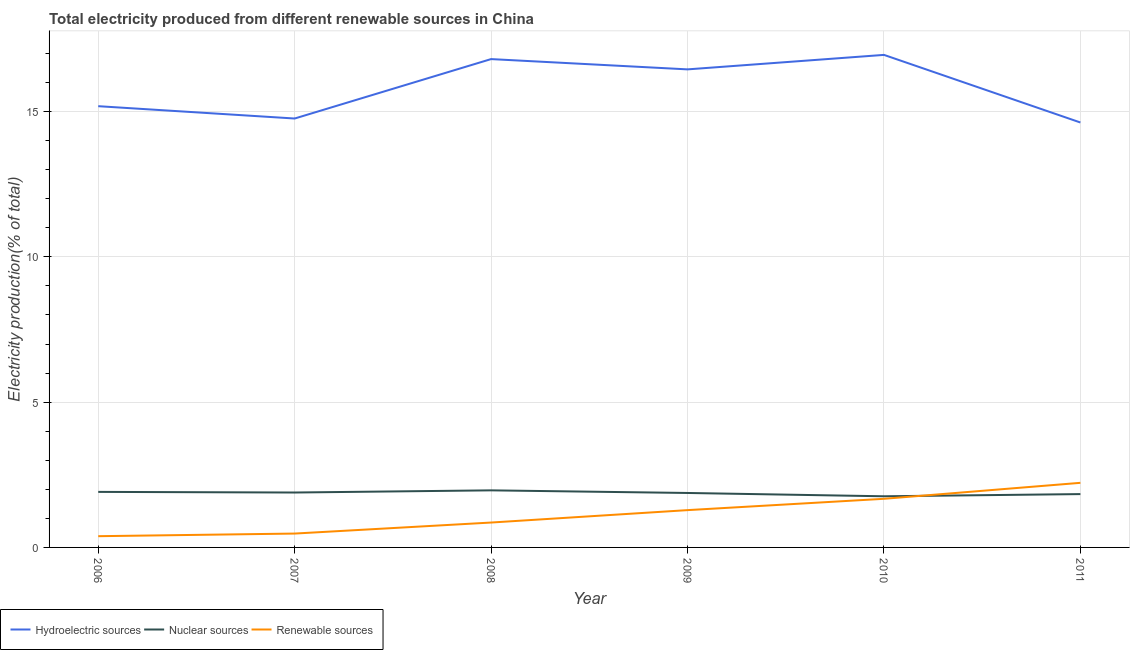Does the line corresponding to percentage of electricity produced by hydroelectric sources intersect with the line corresponding to percentage of electricity produced by renewable sources?
Give a very brief answer. No. Is the number of lines equal to the number of legend labels?
Provide a short and direct response. Yes. What is the percentage of electricity produced by nuclear sources in 2011?
Offer a terse response. 1.84. Across all years, what is the maximum percentage of electricity produced by renewable sources?
Keep it short and to the point. 2.22. Across all years, what is the minimum percentage of electricity produced by nuclear sources?
Your answer should be compact. 1.76. In which year was the percentage of electricity produced by hydroelectric sources maximum?
Keep it short and to the point. 2010. What is the total percentage of electricity produced by renewable sources in the graph?
Make the answer very short. 6.9. What is the difference between the percentage of electricity produced by hydroelectric sources in 2006 and that in 2007?
Provide a short and direct response. 0.42. What is the difference between the percentage of electricity produced by hydroelectric sources in 2006 and the percentage of electricity produced by renewable sources in 2011?
Provide a succinct answer. 12.96. What is the average percentage of electricity produced by renewable sources per year?
Ensure brevity in your answer.  1.15. In the year 2006, what is the difference between the percentage of electricity produced by hydroelectric sources and percentage of electricity produced by renewable sources?
Keep it short and to the point. 14.8. In how many years, is the percentage of electricity produced by nuclear sources greater than 1 %?
Offer a terse response. 6. What is the ratio of the percentage of electricity produced by nuclear sources in 2009 to that in 2010?
Make the answer very short. 1.06. Is the percentage of electricity produced by nuclear sources in 2009 less than that in 2011?
Your answer should be very brief. No. What is the difference between the highest and the second highest percentage of electricity produced by nuclear sources?
Provide a short and direct response. 0.05. What is the difference between the highest and the lowest percentage of electricity produced by hydroelectric sources?
Your answer should be compact. 2.33. Is the sum of the percentage of electricity produced by hydroelectric sources in 2007 and 2009 greater than the maximum percentage of electricity produced by nuclear sources across all years?
Give a very brief answer. Yes. Is the percentage of electricity produced by nuclear sources strictly greater than the percentage of electricity produced by renewable sources over the years?
Ensure brevity in your answer.  No. Is the percentage of electricity produced by renewable sources strictly less than the percentage of electricity produced by hydroelectric sources over the years?
Your answer should be very brief. Yes. What is the difference between two consecutive major ticks on the Y-axis?
Offer a very short reply. 5. Are the values on the major ticks of Y-axis written in scientific E-notation?
Your answer should be compact. No. Where does the legend appear in the graph?
Ensure brevity in your answer.  Bottom left. How are the legend labels stacked?
Your answer should be compact. Horizontal. What is the title of the graph?
Offer a very short reply. Total electricity produced from different renewable sources in China. Does "Ages 20-50" appear as one of the legend labels in the graph?
Your response must be concise. No. What is the label or title of the X-axis?
Make the answer very short. Year. What is the label or title of the Y-axis?
Offer a very short reply. Electricity production(% of total). What is the Electricity production(% of total) in Hydroelectric sources in 2006?
Provide a short and direct response. 15.19. What is the Electricity production(% of total) of Nuclear sources in 2006?
Offer a terse response. 1.91. What is the Electricity production(% of total) of Renewable sources in 2006?
Your answer should be compact. 0.39. What is the Electricity production(% of total) of Hydroelectric sources in 2007?
Make the answer very short. 14.76. What is the Electricity production(% of total) in Nuclear sources in 2007?
Keep it short and to the point. 1.89. What is the Electricity production(% of total) in Renewable sources in 2007?
Your answer should be very brief. 0.48. What is the Electricity production(% of total) of Hydroelectric sources in 2008?
Provide a short and direct response. 16.81. What is the Electricity production(% of total) in Nuclear sources in 2008?
Give a very brief answer. 1.96. What is the Electricity production(% of total) in Renewable sources in 2008?
Give a very brief answer. 0.86. What is the Electricity production(% of total) in Hydroelectric sources in 2009?
Make the answer very short. 16.45. What is the Electricity production(% of total) of Nuclear sources in 2009?
Offer a very short reply. 1.87. What is the Electricity production(% of total) in Renewable sources in 2009?
Make the answer very short. 1.28. What is the Electricity production(% of total) of Hydroelectric sources in 2010?
Offer a terse response. 16.95. What is the Electricity production(% of total) in Nuclear sources in 2010?
Ensure brevity in your answer.  1.76. What is the Electricity production(% of total) in Renewable sources in 2010?
Your response must be concise. 1.67. What is the Electricity production(% of total) of Hydroelectric sources in 2011?
Offer a terse response. 14.62. What is the Electricity production(% of total) of Nuclear sources in 2011?
Give a very brief answer. 1.84. What is the Electricity production(% of total) in Renewable sources in 2011?
Provide a short and direct response. 2.22. Across all years, what is the maximum Electricity production(% of total) in Hydroelectric sources?
Ensure brevity in your answer.  16.95. Across all years, what is the maximum Electricity production(% of total) of Nuclear sources?
Give a very brief answer. 1.96. Across all years, what is the maximum Electricity production(% of total) in Renewable sources?
Make the answer very short. 2.22. Across all years, what is the minimum Electricity production(% of total) of Hydroelectric sources?
Your answer should be very brief. 14.62. Across all years, what is the minimum Electricity production(% of total) of Nuclear sources?
Give a very brief answer. 1.76. Across all years, what is the minimum Electricity production(% of total) in Renewable sources?
Make the answer very short. 0.39. What is the total Electricity production(% of total) in Hydroelectric sources in the graph?
Offer a very short reply. 94.78. What is the total Electricity production(% of total) in Nuclear sources in the graph?
Give a very brief answer. 11.23. What is the total Electricity production(% of total) of Renewable sources in the graph?
Offer a terse response. 6.9. What is the difference between the Electricity production(% of total) in Hydroelectric sources in 2006 and that in 2007?
Your answer should be compact. 0.42. What is the difference between the Electricity production(% of total) in Nuclear sources in 2006 and that in 2007?
Your response must be concise. 0.02. What is the difference between the Electricity production(% of total) of Renewable sources in 2006 and that in 2007?
Provide a succinct answer. -0.09. What is the difference between the Electricity production(% of total) in Hydroelectric sources in 2006 and that in 2008?
Provide a short and direct response. -1.62. What is the difference between the Electricity production(% of total) of Nuclear sources in 2006 and that in 2008?
Make the answer very short. -0.05. What is the difference between the Electricity production(% of total) of Renewable sources in 2006 and that in 2008?
Provide a succinct answer. -0.47. What is the difference between the Electricity production(% of total) in Hydroelectric sources in 2006 and that in 2009?
Provide a succinct answer. -1.27. What is the difference between the Electricity production(% of total) in Nuclear sources in 2006 and that in 2009?
Your answer should be compact. 0.04. What is the difference between the Electricity production(% of total) of Renewable sources in 2006 and that in 2009?
Offer a terse response. -0.9. What is the difference between the Electricity production(% of total) of Hydroelectric sources in 2006 and that in 2010?
Keep it short and to the point. -1.77. What is the difference between the Electricity production(% of total) in Nuclear sources in 2006 and that in 2010?
Ensure brevity in your answer.  0.15. What is the difference between the Electricity production(% of total) in Renewable sources in 2006 and that in 2010?
Provide a succinct answer. -1.29. What is the difference between the Electricity production(% of total) in Hydroelectric sources in 2006 and that in 2011?
Your answer should be very brief. 0.56. What is the difference between the Electricity production(% of total) of Nuclear sources in 2006 and that in 2011?
Provide a short and direct response. 0.08. What is the difference between the Electricity production(% of total) in Renewable sources in 2006 and that in 2011?
Your answer should be compact. -1.84. What is the difference between the Electricity production(% of total) in Hydroelectric sources in 2007 and that in 2008?
Your response must be concise. -2.05. What is the difference between the Electricity production(% of total) in Nuclear sources in 2007 and that in 2008?
Keep it short and to the point. -0.07. What is the difference between the Electricity production(% of total) of Renewable sources in 2007 and that in 2008?
Your answer should be very brief. -0.38. What is the difference between the Electricity production(% of total) of Hydroelectric sources in 2007 and that in 2009?
Make the answer very short. -1.69. What is the difference between the Electricity production(% of total) in Nuclear sources in 2007 and that in 2009?
Keep it short and to the point. 0.02. What is the difference between the Electricity production(% of total) in Renewable sources in 2007 and that in 2009?
Offer a very short reply. -0.81. What is the difference between the Electricity production(% of total) in Hydroelectric sources in 2007 and that in 2010?
Make the answer very short. -2.19. What is the difference between the Electricity production(% of total) in Nuclear sources in 2007 and that in 2010?
Ensure brevity in your answer.  0.13. What is the difference between the Electricity production(% of total) in Renewable sources in 2007 and that in 2010?
Your response must be concise. -1.2. What is the difference between the Electricity production(% of total) in Hydroelectric sources in 2007 and that in 2011?
Your answer should be very brief. 0.14. What is the difference between the Electricity production(% of total) of Nuclear sources in 2007 and that in 2011?
Give a very brief answer. 0.05. What is the difference between the Electricity production(% of total) in Renewable sources in 2007 and that in 2011?
Make the answer very short. -1.75. What is the difference between the Electricity production(% of total) in Hydroelectric sources in 2008 and that in 2009?
Make the answer very short. 0.35. What is the difference between the Electricity production(% of total) of Nuclear sources in 2008 and that in 2009?
Ensure brevity in your answer.  0.09. What is the difference between the Electricity production(% of total) in Renewable sources in 2008 and that in 2009?
Keep it short and to the point. -0.43. What is the difference between the Electricity production(% of total) in Hydroelectric sources in 2008 and that in 2010?
Keep it short and to the point. -0.14. What is the difference between the Electricity production(% of total) of Nuclear sources in 2008 and that in 2010?
Make the answer very short. 0.2. What is the difference between the Electricity production(% of total) in Renewable sources in 2008 and that in 2010?
Your answer should be very brief. -0.82. What is the difference between the Electricity production(% of total) in Hydroelectric sources in 2008 and that in 2011?
Give a very brief answer. 2.18. What is the difference between the Electricity production(% of total) in Nuclear sources in 2008 and that in 2011?
Your response must be concise. 0.13. What is the difference between the Electricity production(% of total) in Renewable sources in 2008 and that in 2011?
Provide a short and direct response. -1.37. What is the difference between the Electricity production(% of total) in Hydroelectric sources in 2009 and that in 2010?
Offer a very short reply. -0.5. What is the difference between the Electricity production(% of total) in Nuclear sources in 2009 and that in 2010?
Offer a terse response. 0.11. What is the difference between the Electricity production(% of total) in Renewable sources in 2009 and that in 2010?
Give a very brief answer. -0.39. What is the difference between the Electricity production(% of total) in Hydroelectric sources in 2009 and that in 2011?
Ensure brevity in your answer.  1.83. What is the difference between the Electricity production(% of total) in Nuclear sources in 2009 and that in 2011?
Offer a terse response. 0.04. What is the difference between the Electricity production(% of total) of Renewable sources in 2009 and that in 2011?
Your response must be concise. -0.94. What is the difference between the Electricity production(% of total) in Hydroelectric sources in 2010 and that in 2011?
Make the answer very short. 2.33. What is the difference between the Electricity production(% of total) of Nuclear sources in 2010 and that in 2011?
Provide a succinct answer. -0.08. What is the difference between the Electricity production(% of total) of Renewable sources in 2010 and that in 2011?
Ensure brevity in your answer.  -0.55. What is the difference between the Electricity production(% of total) in Hydroelectric sources in 2006 and the Electricity production(% of total) in Nuclear sources in 2007?
Make the answer very short. 13.3. What is the difference between the Electricity production(% of total) of Hydroelectric sources in 2006 and the Electricity production(% of total) of Renewable sources in 2007?
Make the answer very short. 14.71. What is the difference between the Electricity production(% of total) of Nuclear sources in 2006 and the Electricity production(% of total) of Renewable sources in 2007?
Provide a short and direct response. 1.43. What is the difference between the Electricity production(% of total) of Hydroelectric sources in 2006 and the Electricity production(% of total) of Nuclear sources in 2008?
Your response must be concise. 13.22. What is the difference between the Electricity production(% of total) in Hydroelectric sources in 2006 and the Electricity production(% of total) in Renewable sources in 2008?
Make the answer very short. 14.33. What is the difference between the Electricity production(% of total) in Nuclear sources in 2006 and the Electricity production(% of total) in Renewable sources in 2008?
Your answer should be very brief. 1.05. What is the difference between the Electricity production(% of total) of Hydroelectric sources in 2006 and the Electricity production(% of total) of Nuclear sources in 2009?
Give a very brief answer. 13.31. What is the difference between the Electricity production(% of total) in Hydroelectric sources in 2006 and the Electricity production(% of total) in Renewable sources in 2009?
Make the answer very short. 13.9. What is the difference between the Electricity production(% of total) in Nuclear sources in 2006 and the Electricity production(% of total) in Renewable sources in 2009?
Give a very brief answer. 0.63. What is the difference between the Electricity production(% of total) in Hydroelectric sources in 2006 and the Electricity production(% of total) in Nuclear sources in 2010?
Keep it short and to the point. 13.42. What is the difference between the Electricity production(% of total) in Hydroelectric sources in 2006 and the Electricity production(% of total) in Renewable sources in 2010?
Keep it short and to the point. 13.51. What is the difference between the Electricity production(% of total) of Nuclear sources in 2006 and the Electricity production(% of total) of Renewable sources in 2010?
Your answer should be compact. 0.24. What is the difference between the Electricity production(% of total) in Hydroelectric sources in 2006 and the Electricity production(% of total) in Nuclear sources in 2011?
Your response must be concise. 13.35. What is the difference between the Electricity production(% of total) in Hydroelectric sources in 2006 and the Electricity production(% of total) in Renewable sources in 2011?
Make the answer very short. 12.96. What is the difference between the Electricity production(% of total) in Nuclear sources in 2006 and the Electricity production(% of total) in Renewable sources in 2011?
Offer a terse response. -0.31. What is the difference between the Electricity production(% of total) of Hydroelectric sources in 2007 and the Electricity production(% of total) of Nuclear sources in 2008?
Offer a terse response. 12.8. What is the difference between the Electricity production(% of total) of Hydroelectric sources in 2007 and the Electricity production(% of total) of Renewable sources in 2008?
Give a very brief answer. 13.9. What is the difference between the Electricity production(% of total) of Nuclear sources in 2007 and the Electricity production(% of total) of Renewable sources in 2008?
Your answer should be very brief. 1.03. What is the difference between the Electricity production(% of total) of Hydroelectric sources in 2007 and the Electricity production(% of total) of Nuclear sources in 2009?
Keep it short and to the point. 12.89. What is the difference between the Electricity production(% of total) in Hydroelectric sources in 2007 and the Electricity production(% of total) in Renewable sources in 2009?
Your answer should be compact. 13.48. What is the difference between the Electricity production(% of total) in Nuclear sources in 2007 and the Electricity production(% of total) in Renewable sources in 2009?
Ensure brevity in your answer.  0.61. What is the difference between the Electricity production(% of total) in Hydroelectric sources in 2007 and the Electricity production(% of total) in Nuclear sources in 2010?
Keep it short and to the point. 13. What is the difference between the Electricity production(% of total) in Hydroelectric sources in 2007 and the Electricity production(% of total) in Renewable sources in 2010?
Your response must be concise. 13.09. What is the difference between the Electricity production(% of total) in Nuclear sources in 2007 and the Electricity production(% of total) in Renewable sources in 2010?
Give a very brief answer. 0.22. What is the difference between the Electricity production(% of total) in Hydroelectric sources in 2007 and the Electricity production(% of total) in Nuclear sources in 2011?
Offer a very short reply. 12.93. What is the difference between the Electricity production(% of total) of Hydroelectric sources in 2007 and the Electricity production(% of total) of Renewable sources in 2011?
Provide a succinct answer. 12.54. What is the difference between the Electricity production(% of total) of Hydroelectric sources in 2008 and the Electricity production(% of total) of Nuclear sources in 2009?
Your answer should be compact. 14.93. What is the difference between the Electricity production(% of total) of Hydroelectric sources in 2008 and the Electricity production(% of total) of Renewable sources in 2009?
Provide a succinct answer. 15.52. What is the difference between the Electricity production(% of total) of Nuclear sources in 2008 and the Electricity production(% of total) of Renewable sources in 2009?
Ensure brevity in your answer.  0.68. What is the difference between the Electricity production(% of total) of Hydroelectric sources in 2008 and the Electricity production(% of total) of Nuclear sources in 2010?
Provide a short and direct response. 15.05. What is the difference between the Electricity production(% of total) of Hydroelectric sources in 2008 and the Electricity production(% of total) of Renewable sources in 2010?
Keep it short and to the point. 15.13. What is the difference between the Electricity production(% of total) in Nuclear sources in 2008 and the Electricity production(% of total) in Renewable sources in 2010?
Offer a terse response. 0.29. What is the difference between the Electricity production(% of total) of Hydroelectric sources in 2008 and the Electricity production(% of total) of Nuclear sources in 2011?
Your answer should be compact. 14.97. What is the difference between the Electricity production(% of total) in Hydroelectric sources in 2008 and the Electricity production(% of total) in Renewable sources in 2011?
Keep it short and to the point. 14.58. What is the difference between the Electricity production(% of total) in Nuclear sources in 2008 and the Electricity production(% of total) in Renewable sources in 2011?
Provide a short and direct response. -0.26. What is the difference between the Electricity production(% of total) of Hydroelectric sources in 2009 and the Electricity production(% of total) of Nuclear sources in 2010?
Offer a terse response. 14.69. What is the difference between the Electricity production(% of total) of Hydroelectric sources in 2009 and the Electricity production(% of total) of Renewable sources in 2010?
Offer a terse response. 14.78. What is the difference between the Electricity production(% of total) of Nuclear sources in 2009 and the Electricity production(% of total) of Renewable sources in 2010?
Offer a very short reply. 0.2. What is the difference between the Electricity production(% of total) of Hydroelectric sources in 2009 and the Electricity production(% of total) of Nuclear sources in 2011?
Offer a very short reply. 14.62. What is the difference between the Electricity production(% of total) of Hydroelectric sources in 2009 and the Electricity production(% of total) of Renewable sources in 2011?
Your response must be concise. 14.23. What is the difference between the Electricity production(% of total) in Nuclear sources in 2009 and the Electricity production(% of total) in Renewable sources in 2011?
Ensure brevity in your answer.  -0.35. What is the difference between the Electricity production(% of total) of Hydroelectric sources in 2010 and the Electricity production(% of total) of Nuclear sources in 2011?
Your response must be concise. 15.12. What is the difference between the Electricity production(% of total) in Hydroelectric sources in 2010 and the Electricity production(% of total) in Renewable sources in 2011?
Keep it short and to the point. 14.73. What is the difference between the Electricity production(% of total) of Nuclear sources in 2010 and the Electricity production(% of total) of Renewable sources in 2011?
Keep it short and to the point. -0.46. What is the average Electricity production(% of total) in Hydroelectric sources per year?
Keep it short and to the point. 15.8. What is the average Electricity production(% of total) in Nuclear sources per year?
Your response must be concise. 1.87. What is the average Electricity production(% of total) in Renewable sources per year?
Give a very brief answer. 1.15. In the year 2006, what is the difference between the Electricity production(% of total) in Hydroelectric sources and Electricity production(% of total) in Nuclear sources?
Your answer should be compact. 13.27. In the year 2006, what is the difference between the Electricity production(% of total) of Hydroelectric sources and Electricity production(% of total) of Renewable sources?
Ensure brevity in your answer.  14.8. In the year 2006, what is the difference between the Electricity production(% of total) in Nuclear sources and Electricity production(% of total) in Renewable sources?
Make the answer very short. 1.52. In the year 2007, what is the difference between the Electricity production(% of total) in Hydroelectric sources and Electricity production(% of total) in Nuclear sources?
Ensure brevity in your answer.  12.87. In the year 2007, what is the difference between the Electricity production(% of total) of Hydroelectric sources and Electricity production(% of total) of Renewable sources?
Ensure brevity in your answer.  14.28. In the year 2007, what is the difference between the Electricity production(% of total) in Nuclear sources and Electricity production(% of total) in Renewable sources?
Keep it short and to the point. 1.41. In the year 2008, what is the difference between the Electricity production(% of total) in Hydroelectric sources and Electricity production(% of total) in Nuclear sources?
Provide a succinct answer. 14.84. In the year 2008, what is the difference between the Electricity production(% of total) in Hydroelectric sources and Electricity production(% of total) in Renewable sources?
Keep it short and to the point. 15.95. In the year 2008, what is the difference between the Electricity production(% of total) in Nuclear sources and Electricity production(% of total) in Renewable sources?
Your answer should be compact. 1.11. In the year 2009, what is the difference between the Electricity production(% of total) of Hydroelectric sources and Electricity production(% of total) of Nuclear sources?
Your answer should be compact. 14.58. In the year 2009, what is the difference between the Electricity production(% of total) in Hydroelectric sources and Electricity production(% of total) in Renewable sources?
Ensure brevity in your answer.  15.17. In the year 2009, what is the difference between the Electricity production(% of total) of Nuclear sources and Electricity production(% of total) of Renewable sources?
Your response must be concise. 0.59. In the year 2010, what is the difference between the Electricity production(% of total) in Hydroelectric sources and Electricity production(% of total) in Nuclear sources?
Your response must be concise. 15.19. In the year 2010, what is the difference between the Electricity production(% of total) in Hydroelectric sources and Electricity production(% of total) in Renewable sources?
Offer a terse response. 15.28. In the year 2010, what is the difference between the Electricity production(% of total) in Nuclear sources and Electricity production(% of total) in Renewable sources?
Give a very brief answer. 0.09. In the year 2011, what is the difference between the Electricity production(% of total) in Hydroelectric sources and Electricity production(% of total) in Nuclear sources?
Provide a short and direct response. 12.79. In the year 2011, what is the difference between the Electricity production(% of total) of Hydroelectric sources and Electricity production(% of total) of Renewable sources?
Provide a succinct answer. 12.4. In the year 2011, what is the difference between the Electricity production(% of total) of Nuclear sources and Electricity production(% of total) of Renewable sources?
Provide a succinct answer. -0.39. What is the ratio of the Electricity production(% of total) in Hydroelectric sources in 2006 to that in 2007?
Make the answer very short. 1.03. What is the ratio of the Electricity production(% of total) of Nuclear sources in 2006 to that in 2007?
Offer a very short reply. 1.01. What is the ratio of the Electricity production(% of total) in Renewable sources in 2006 to that in 2007?
Offer a terse response. 0.81. What is the ratio of the Electricity production(% of total) in Hydroelectric sources in 2006 to that in 2008?
Provide a short and direct response. 0.9. What is the ratio of the Electricity production(% of total) of Nuclear sources in 2006 to that in 2008?
Provide a short and direct response. 0.97. What is the ratio of the Electricity production(% of total) in Renewable sources in 2006 to that in 2008?
Your answer should be very brief. 0.45. What is the ratio of the Electricity production(% of total) of Hydroelectric sources in 2006 to that in 2009?
Offer a terse response. 0.92. What is the ratio of the Electricity production(% of total) in Nuclear sources in 2006 to that in 2009?
Offer a terse response. 1.02. What is the ratio of the Electricity production(% of total) in Renewable sources in 2006 to that in 2009?
Your response must be concise. 0.3. What is the ratio of the Electricity production(% of total) of Hydroelectric sources in 2006 to that in 2010?
Provide a succinct answer. 0.9. What is the ratio of the Electricity production(% of total) in Nuclear sources in 2006 to that in 2010?
Ensure brevity in your answer.  1.09. What is the ratio of the Electricity production(% of total) of Renewable sources in 2006 to that in 2010?
Your answer should be compact. 0.23. What is the ratio of the Electricity production(% of total) in Hydroelectric sources in 2006 to that in 2011?
Ensure brevity in your answer.  1.04. What is the ratio of the Electricity production(% of total) in Nuclear sources in 2006 to that in 2011?
Provide a succinct answer. 1.04. What is the ratio of the Electricity production(% of total) in Renewable sources in 2006 to that in 2011?
Provide a short and direct response. 0.17. What is the ratio of the Electricity production(% of total) of Hydroelectric sources in 2007 to that in 2008?
Provide a succinct answer. 0.88. What is the ratio of the Electricity production(% of total) in Nuclear sources in 2007 to that in 2008?
Your response must be concise. 0.96. What is the ratio of the Electricity production(% of total) of Renewable sources in 2007 to that in 2008?
Ensure brevity in your answer.  0.56. What is the ratio of the Electricity production(% of total) of Hydroelectric sources in 2007 to that in 2009?
Offer a terse response. 0.9. What is the ratio of the Electricity production(% of total) of Nuclear sources in 2007 to that in 2009?
Your answer should be compact. 1.01. What is the ratio of the Electricity production(% of total) in Renewable sources in 2007 to that in 2009?
Keep it short and to the point. 0.37. What is the ratio of the Electricity production(% of total) of Hydroelectric sources in 2007 to that in 2010?
Give a very brief answer. 0.87. What is the ratio of the Electricity production(% of total) of Nuclear sources in 2007 to that in 2010?
Make the answer very short. 1.07. What is the ratio of the Electricity production(% of total) of Renewable sources in 2007 to that in 2010?
Ensure brevity in your answer.  0.29. What is the ratio of the Electricity production(% of total) of Hydroelectric sources in 2007 to that in 2011?
Offer a very short reply. 1.01. What is the ratio of the Electricity production(% of total) in Nuclear sources in 2007 to that in 2011?
Offer a terse response. 1.03. What is the ratio of the Electricity production(% of total) of Renewable sources in 2007 to that in 2011?
Provide a short and direct response. 0.21. What is the ratio of the Electricity production(% of total) in Hydroelectric sources in 2008 to that in 2009?
Your answer should be compact. 1.02. What is the ratio of the Electricity production(% of total) in Nuclear sources in 2008 to that in 2009?
Your response must be concise. 1.05. What is the ratio of the Electricity production(% of total) of Renewable sources in 2008 to that in 2009?
Ensure brevity in your answer.  0.67. What is the ratio of the Electricity production(% of total) in Nuclear sources in 2008 to that in 2010?
Ensure brevity in your answer.  1.12. What is the ratio of the Electricity production(% of total) of Renewable sources in 2008 to that in 2010?
Keep it short and to the point. 0.51. What is the ratio of the Electricity production(% of total) in Hydroelectric sources in 2008 to that in 2011?
Provide a short and direct response. 1.15. What is the ratio of the Electricity production(% of total) in Nuclear sources in 2008 to that in 2011?
Provide a succinct answer. 1.07. What is the ratio of the Electricity production(% of total) of Renewable sources in 2008 to that in 2011?
Offer a terse response. 0.39. What is the ratio of the Electricity production(% of total) of Hydroelectric sources in 2009 to that in 2010?
Make the answer very short. 0.97. What is the ratio of the Electricity production(% of total) in Nuclear sources in 2009 to that in 2010?
Keep it short and to the point. 1.06. What is the ratio of the Electricity production(% of total) in Renewable sources in 2009 to that in 2010?
Provide a short and direct response. 0.77. What is the ratio of the Electricity production(% of total) in Hydroelectric sources in 2009 to that in 2011?
Keep it short and to the point. 1.12. What is the ratio of the Electricity production(% of total) of Nuclear sources in 2009 to that in 2011?
Provide a succinct answer. 1.02. What is the ratio of the Electricity production(% of total) in Renewable sources in 2009 to that in 2011?
Keep it short and to the point. 0.58. What is the ratio of the Electricity production(% of total) in Hydroelectric sources in 2010 to that in 2011?
Your answer should be compact. 1.16. What is the ratio of the Electricity production(% of total) of Nuclear sources in 2010 to that in 2011?
Offer a terse response. 0.96. What is the ratio of the Electricity production(% of total) of Renewable sources in 2010 to that in 2011?
Offer a very short reply. 0.75. What is the difference between the highest and the second highest Electricity production(% of total) of Hydroelectric sources?
Provide a short and direct response. 0.14. What is the difference between the highest and the second highest Electricity production(% of total) of Nuclear sources?
Keep it short and to the point. 0.05. What is the difference between the highest and the second highest Electricity production(% of total) in Renewable sources?
Make the answer very short. 0.55. What is the difference between the highest and the lowest Electricity production(% of total) in Hydroelectric sources?
Offer a very short reply. 2.33. What is the difference between the highest and the lowest Electricity production(% of total) in Nuclear sources?
Give a very brief answer. 0.2. What is the difference between the highest and the lowest Electricity production(% of total) in Renewable sources?
Your answer should be very brief. 1.84. 